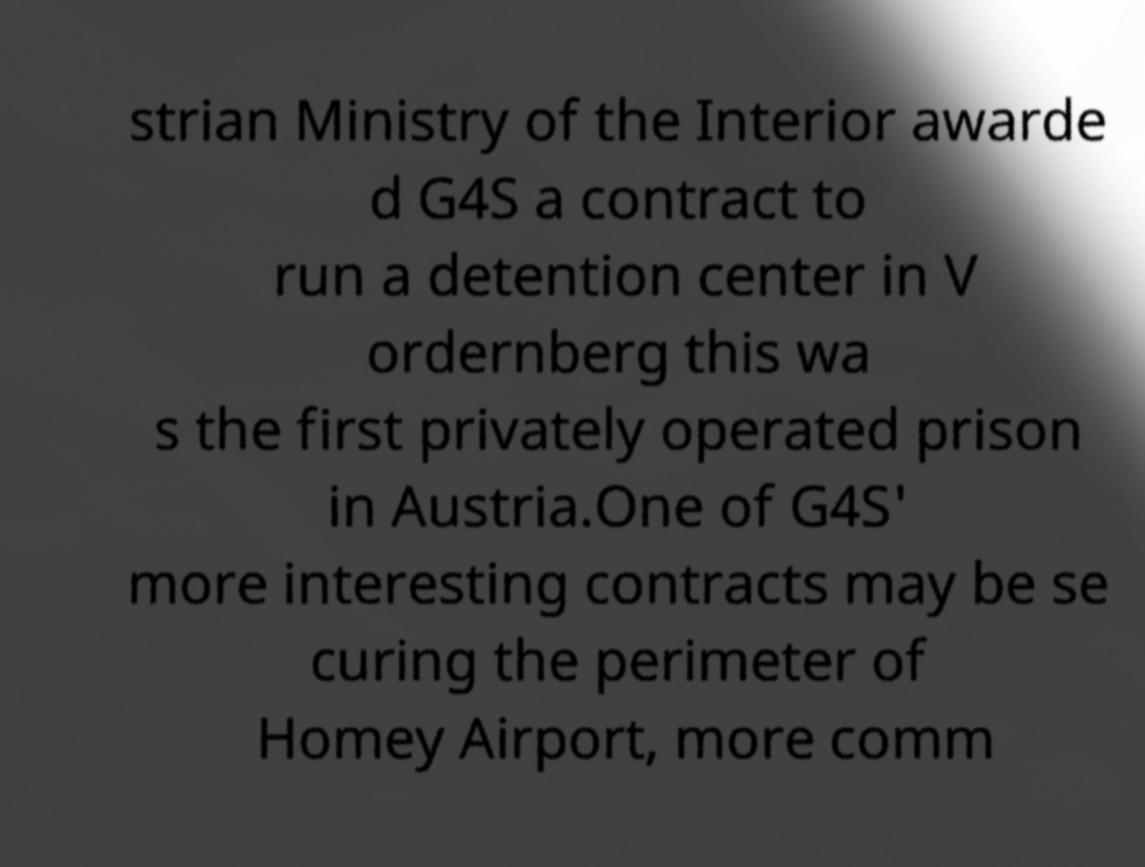There's text embedded in this image that I need extracted. Can you transcribe it verbatim? strian Ministry of the Interior awarde d G4S a contract to run a detention center in V ordernberg this wa s the first privately operated prison in Austria.One of G4S' more interesting contracts may be se curing the perimeter of Homey Airport, more comm 